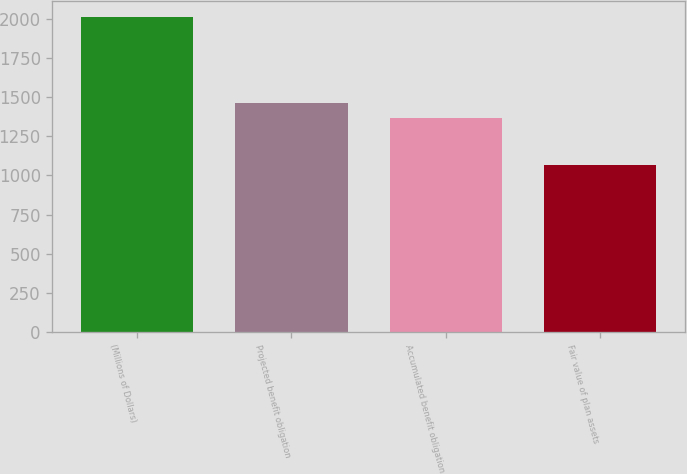<chart> <loc_0><loc_0><loc_500><loc_500><bar_chart><fcel>(Millions of Dollars)<fcel>Projected benefit obligation<fcel>Accumulated benefit obligation<fcel>Fair value of plan assets<nl><fcel>2017<fcel>1463.55<fcel>1368.7<fcel>1068.5<nl></chart> 